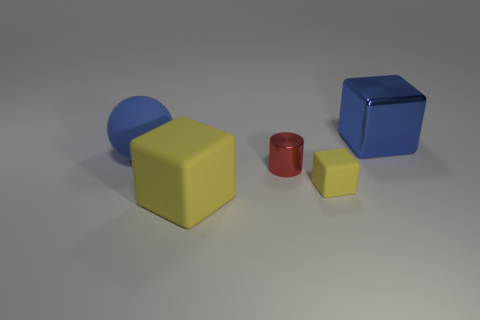Add 2 small metal cylinders. How many objects exist? 7 Subtract all spheres. How many objects are left? 4 Subtract 0 cyan cylinders. How many objects are left? 5 Subtract all small red metal spheres. Subtract all blue matte objects. How many objects are left? 4 Add 3 small red cylinders. How many small red cylinders are left? 4 Add 3 small red things. How many small red things exist? 4 